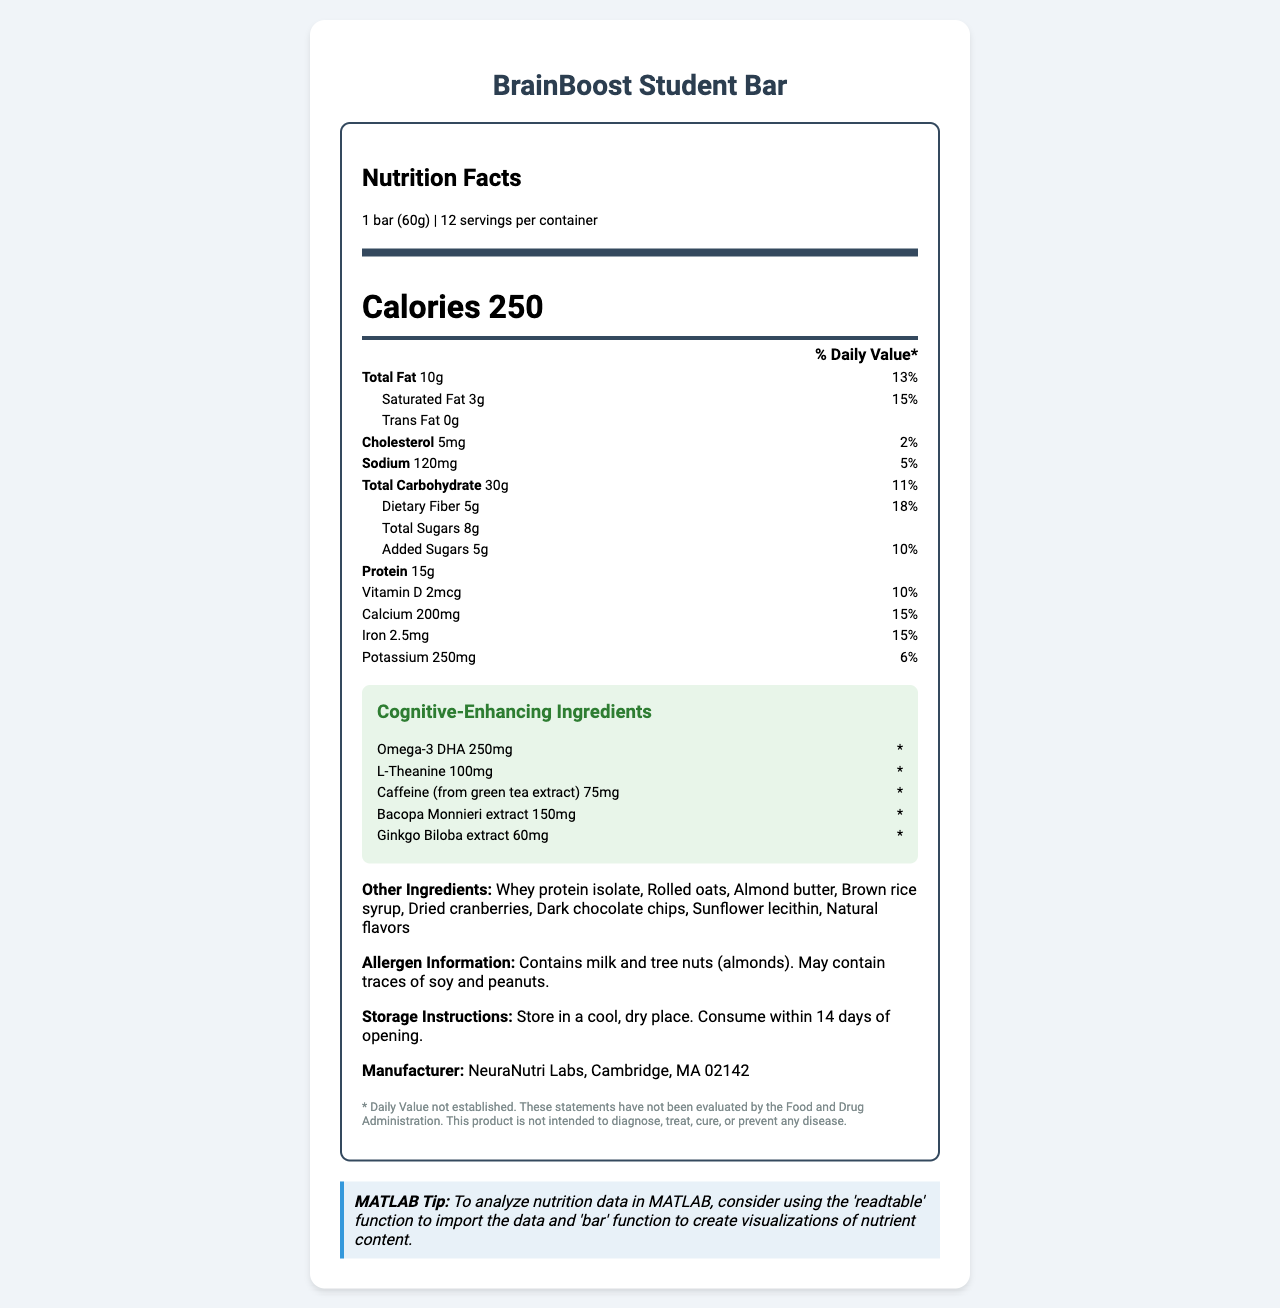what is the serving size of the BrainBoost Student Bar? The serving size is clearly listed at the top of the document under the "Nutrition Facts" section.
Answer: 1 bar (60g) how many calories does one bar contain? The calories content is prominently displayed in a larger font within the "Nutrition Facts" section.
Answer: 250 how much protein is in each serving? The protein content is listed as one of the nutrients in the "Nutrition Facts".
Answer: 15g how many servings are in each container? The number of servings per container is mentioned next to the serving size.
Answer: 12 what is the amount of saturated fat in one bar? The amount of saturated fat is listed along with other nutrients such as total fat.
Answer: 3g how much dietary fiber does the bar contain? The amount of dietary fiber is mentioned under the "Total Carbohydrate" section in the "Nutrition Facts".
Answer: 5g How much is the daily value percentage of calcium in one serving? A. 10% B. 15% C. 6% D. 5% The daily value percentage for calcium is listed along with its amount in the "Nutrition Facts".
Answer: B. 15% Which cognitive-enhancing ingredient has the highest amount? A. Omega-3 DHA B. L-Theanine C. Caffeine D. Bacopa Monnieri Omega-3 DHA has the highest amount listed at 250mg, compared to the other cognitive-enhancing ingredients.
Answer: A. Omega-3 DHA Does the bar contain any trans fat? The document explicitly states that the trans fat content is 0g.
Answer: No Does the label include any information about allergens? The allergen information is mentioned towards the end of the document, noting that it contains milk and tree nuts (almonds) and may contain traces of soy and peanuts.
Answer: Yes Summarize the main idea of the document. The document covers all relevant details you would find on a nutrition label, focusing on both standard nutritional facts and specific cognitive-enhancing ingredients, along with additional information like allergens and storage.
Answer: The document provides a comprehensive overview of the nutritional content of the BrainBoost Student Bar, highlighting its serving size, calories, and various nutrients including cognitive-enhancing ingredients. It also lists the other ingredients, allergen information, storage instructions, and a disclaimer. What is the exact daily value percentage of potassium? The document lists the amount of potassium as 250mg but does not provide the percentage of the daily value for potassium.
Answer: Cannot be determined Who is the manufacturer of the BrainBoost Student Bar? The manufacturer's information is listed towards the end of the document.
Answer: NeuraNutri Labs, Cambridge, MA 02142 What should you do if you want to consume the bar after opening it? The storage instructions state that the bar should be consumed within 14 days of opening.
Answer: Consume within 14 days of opening What is the main source of caffeine in the BrainBoost Student Bar? The document lists "Caffeine (from green tea extract)" as one of the cognitive-enhancing ingredients.
Answer: Green tea extract Can you find instructions to analyze the nutrition data in MATLAB in the document? There's a "MATLAB Tip" at the end of the document, which mentions using the 'readtable' function to import data and 'bar' function to create visualizations.
Answer: Yes 